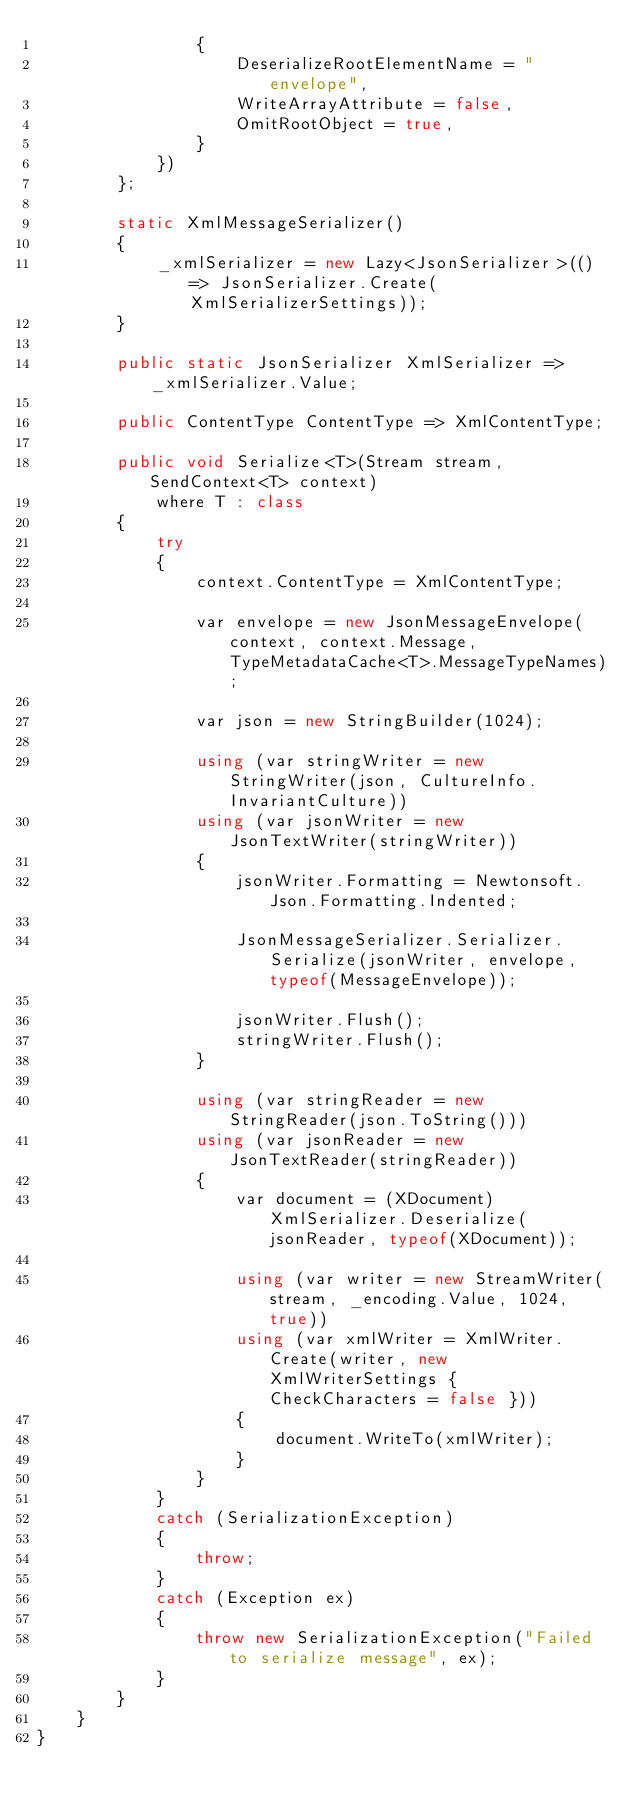Convert code to text. <code><loc_0><loc_0><loc_500><loc_500><_C#_>                {
                    DeserializeRootElementName = "envelope",
                    WriteArrayAttribute = false,
                    OmitRootObject = true,
                }
            })
        };

        static XmlMessageSerializer()
        {
            _xmlSerializer = new Lazy<JsonSerializer>(() => JsonSerializer.Create(XmlSerializerSettings));
        }

        public static JsonSerializer XmlSerializer => _xmlSerializer.Value;

        public ContentType ContentType => XmlContentType;

        public void Serialize<T>(Stream stream, SendContext<T> context)
            where T : class
        {
            try
            {
                context.ContentType = XmlContentType;

                var envelope = new JsonMessageEnvelope(context, context.Message, TypeMetadataCache<T>.MessageTypeNames);

                var json = new StringBuilder(1024);

                using (var stringWriter = new StringWriter(json, CultureInfo.InvariantCulture))
                using (var jsonWriter = new JsonTextWriter(stringWriter))
                {
                    jsonWriter.Formatting = Newtonsoft.Json.Formatting.Indented;

                    JsonMessageSerializer.Serializer.Serialize(jsonWriter, envelope, typeof(MessageEnvelope));

                    jsonWriter.Flush();
                    stringWriter.Flush();
                }
                
                using (var stringReader = new StringReader(json.ToString()))
                using (var jsonReader = new JsonTextReader(stringReader))
                {
                    var document = (XDocument)XmlSerializer.Deserialize(jsonReader, typeof(XDocument));                    

                    using (var writer = new StreamWriter(stream, _encoding.Value, 1024, true))
                    using (var xmlWriter = XmlWriter.Create(writer, new XmlWriterSettings { CheckCharacters = false }))
                    {
                        document.WriteTo(xmlWriter);
                    }
                }
            }
            catch (SerializationException)
            {
                throw;
            }
            catch (Exception ex)
            {
                throw new SerializationException("Failed to serialize message", ex);
            }
        }
    }
}</code> 